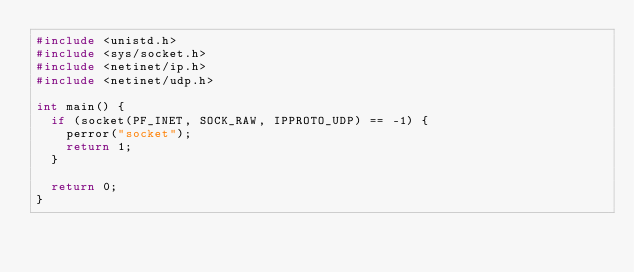Convert code to text. <code><loc_0><loc_0><loc_500><loc_500><_C_>#include <unistd.h>
#include <sys/socket.h>
#include <netinet/ip.h>
#include <netinet/udp.h>

int main() {
	if (socket(PF_INET, SOCK_RAW, IPPROTO_UDP) == -1) {
		perror("socket");
		return 1;
	}

	return 0;
}
</code> 